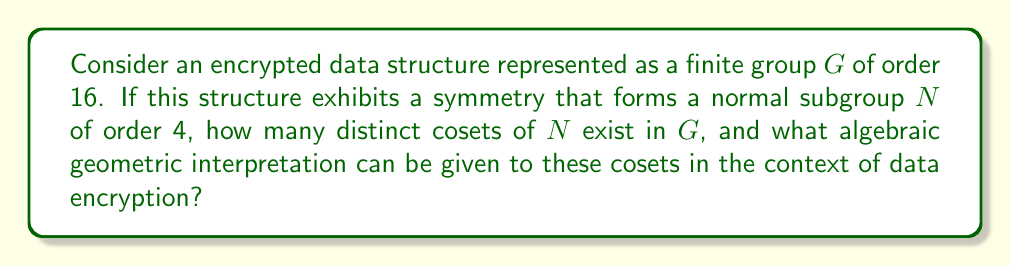Solve this math problem. 1. Given:
   - $G$ is a finite group of order 16
   - $N$ is a normal subgroup of $G$ with order 4

2. To find the number of distinct cosets, we use Lagrange's theorem:
   $$ |G| = |N| \cdot [G:N] $$
   Where $[G:N]$ is the index of $N$ in $G$, which equals the number of cosets.

3. Substituting the known values:
   $$ 16 = 4 \cdot [G:N] $$

4. Solving for $[G:N]$:
   $$ [G:N] = 16 / 4 = 4 $$

5. Algebraic geometric interpretation:
   - Each coset can be viewed as a point in a projective space $\mathbb{P}^3$
   - The group action of $G$ on these cosets induces symmetries in this space
   - These symmetries form a group of automorphisms of the projective space

6. In the context of data encryption:
   - The cosets represent distinct encrypted states
   - The symmetries between cosets reflect the structure-preserving properties of the encryption
   - This interpretation allows for the study of encryption robustness through geometric invariants
Answer: 4 cosets; points in $\mathbb{P}^3$ with $G$-action symmetries 